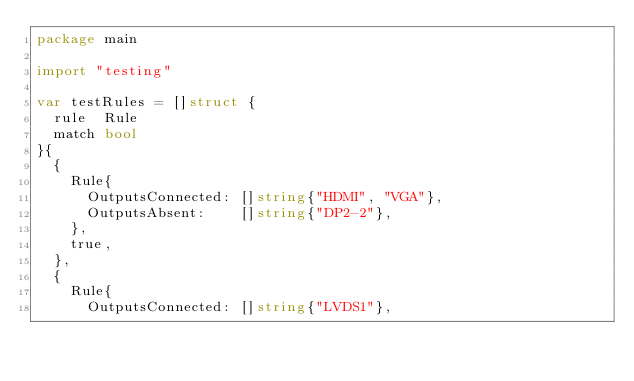Convert code to text. <code><loc_0><loc_0><loc_500><loc_500><_Go_>package main

import "testing"

var testRules = []struct {
	rule  Rule
	match bool
}{
	{
		Rule{
			OutputsConnected: []string{"HDMI", "VGA"},
			OutputsAbsent:    []string{"DP2-2"},
		},
		true,
	},
	{
		Rule{
			OutputsConnected: []string{"LVDS1"},</code> 